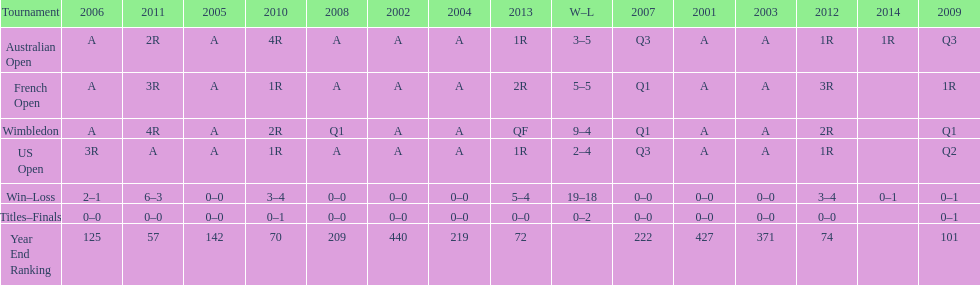Between 2001 and 2006, what was the average position of this participant? 287. 